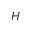<formula> <loc_0><loc_0><loc_500><loc_500>H</formula> 